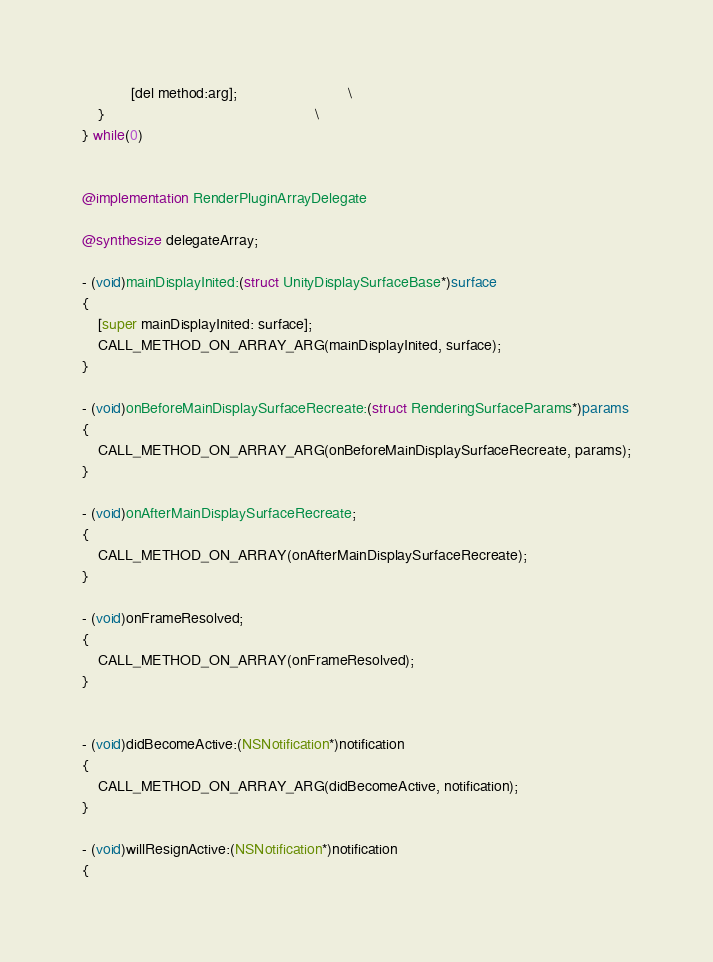Convert code to text. <code><loc_0><loc_0><loc_500><loc_500><_ObjectiveC_>            [del method:arg];                           \
    }                                                   \
} while(0)


@implementation RenderPluginArrayDelegate

@synthesize delegateArray;

- (void)mainDisplayInited:(struct UnityDisplaySurfaceBase*)surface
{
    [super mainDisplayInited: surface];
    CALL_METHOD_ON_ARRAY_ARG(mainDisplayInited, surface);
}

- (void)onBeforeMainDisplaySurfaceRecreate:(struct RenderingSurfaceParams*)params
{
    CALL_METHOD_ON_ARRAY_ARG(onBeforeMainDisplaySurfaceRecreate, params);
}

- (void)onAfterMainDisplaySurfaceRecreate;
{
    CALL_METHOD_ON_ARRAY(onAfterMainDisplaySurfaceRecreate);
}

- (void)onFrameResolved;
{
    CALL_METHOD_ON_ARRAY(onFrameResolved);
}


- (void)didBecomeActive:(NSNotification*)notification
{
    CALL_METHOD_ON_ARRAY_ARG(didBecomeActive, notification);
}

- (void)willResignActive:(NSNotification*)notification
{</code> 